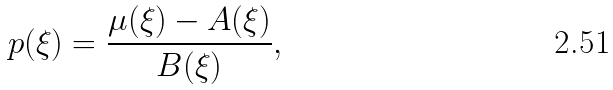Convert formula to latex. <formula><loc_0><loc_0><loc_500><loc_500>p ( \xi ) = \frac { \mu ( \xi ) - A ( \xi ) } { B ( \xi ) } ,</formula> 